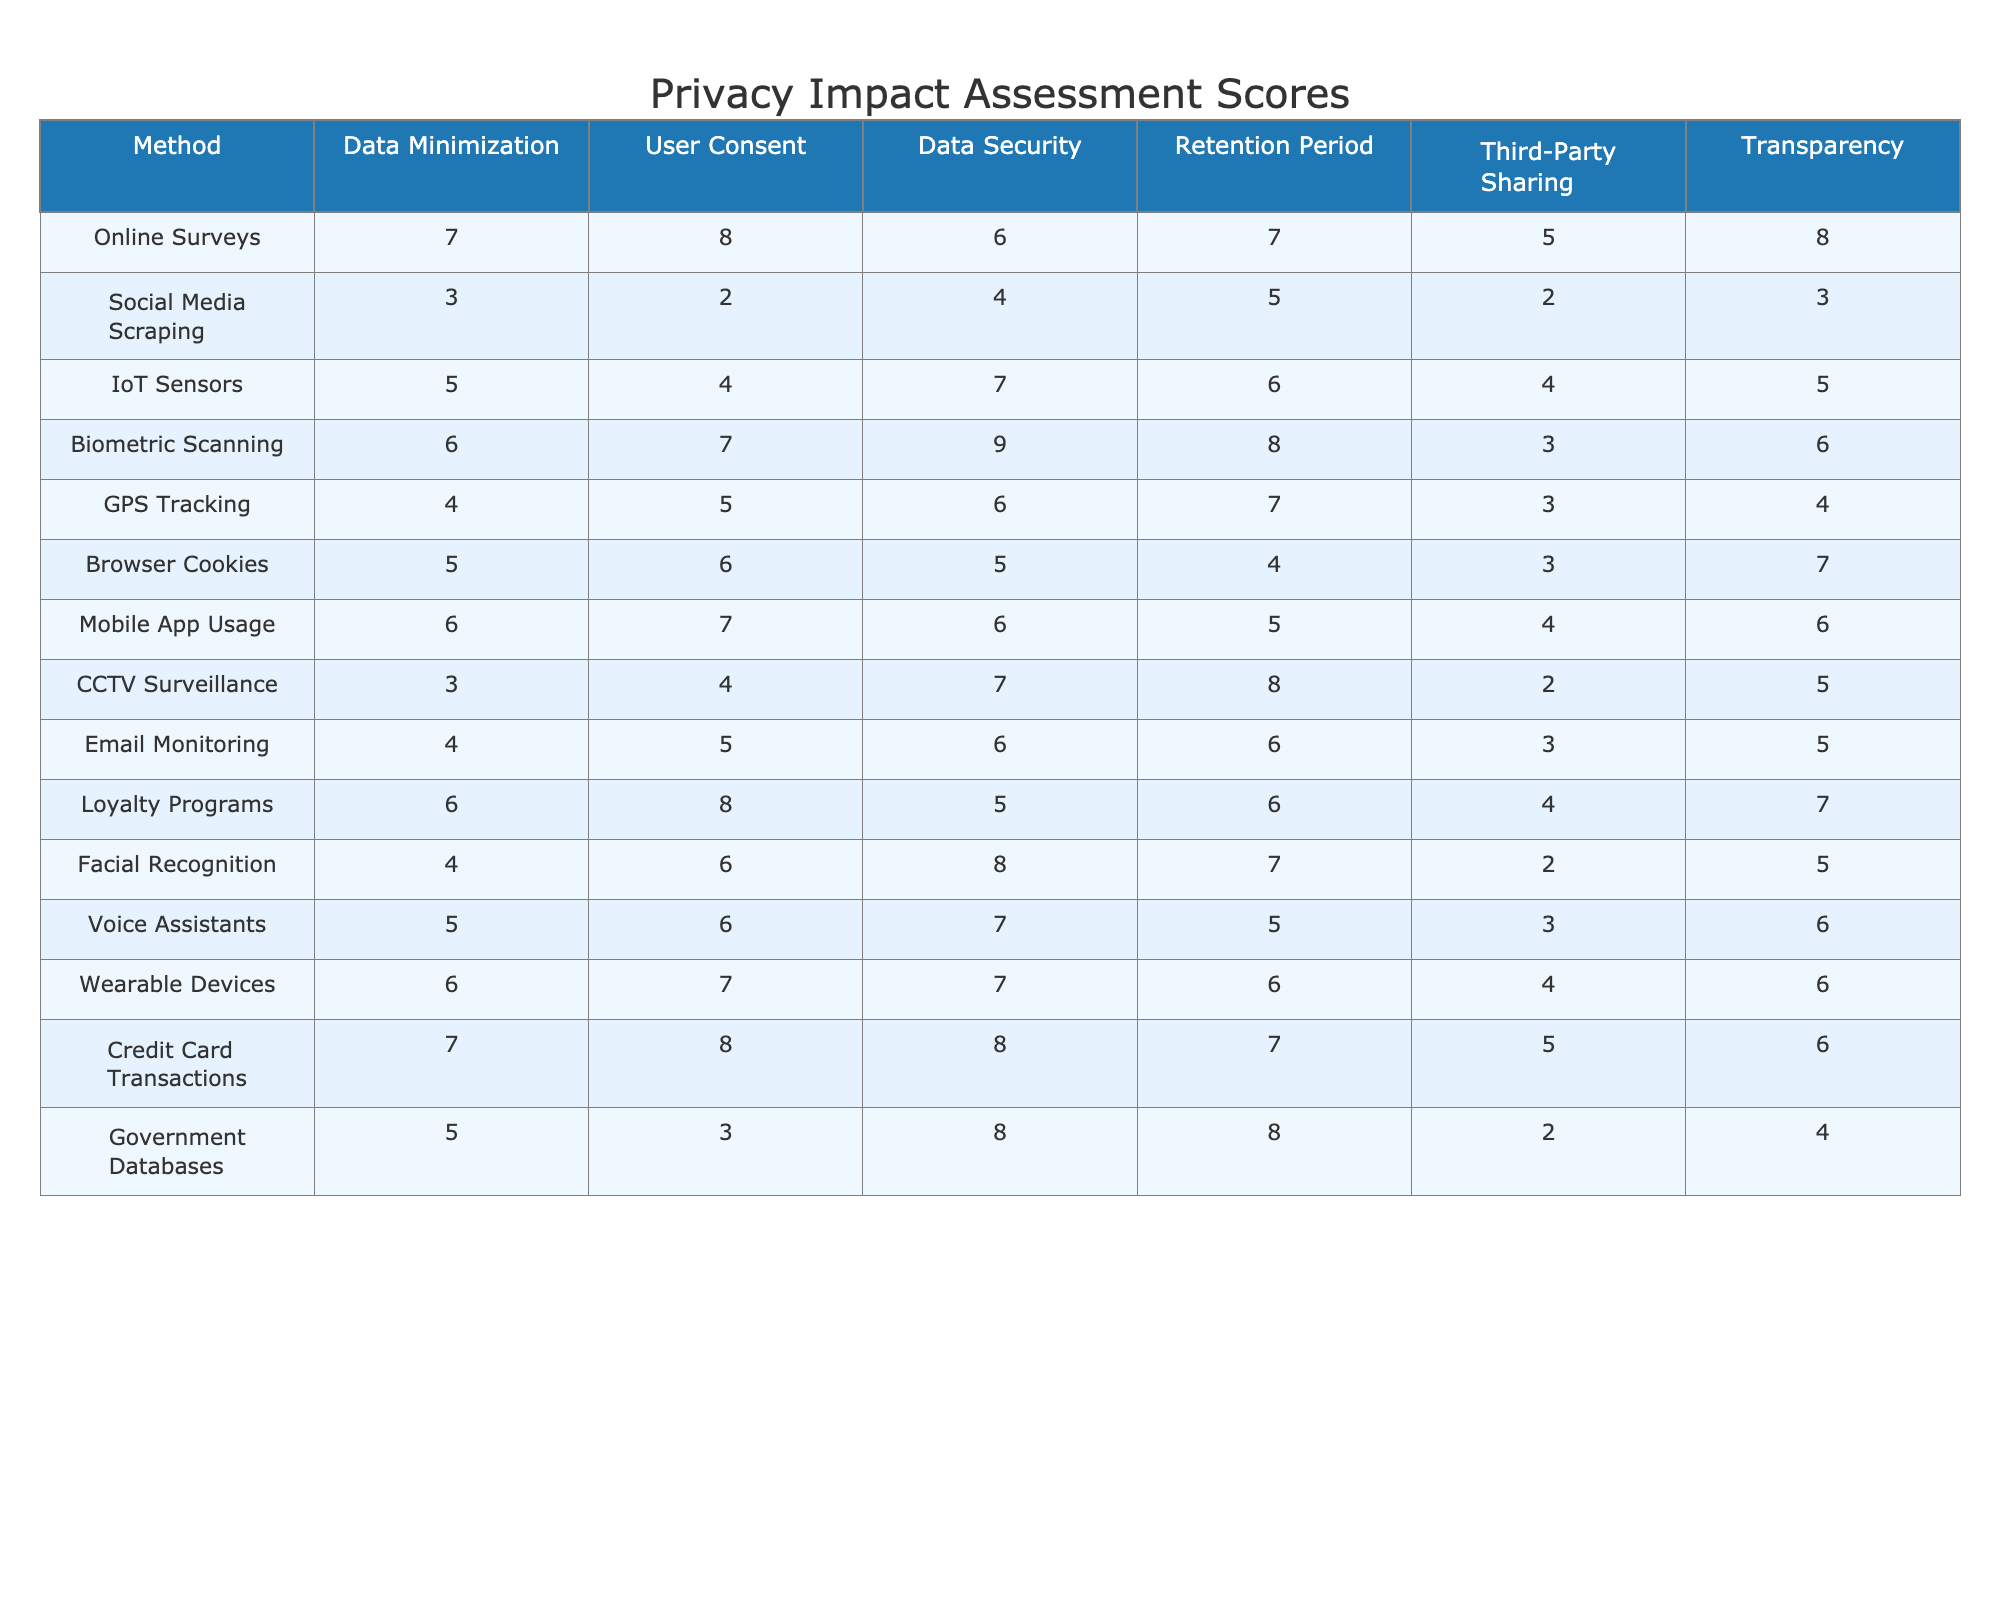What is the highest score for User Consent? The highest score for User Consent in the table is found by comparing all the values in the User Consent column. The highest value is 8, seen in Online Surveys and Loyalty Programs.
Answer: 8 Which method has the lowest Data Security score? By examining the Data Security column, we identify the lowest value. The lowest score is 4, which corresponds to Social Media Scraping.
Answer: 4 What is the average score for Data Minimization across all methods? To calculate the average for Data Minimization, we sum all the scores: (7 + 3 + 5 + 6 + 4 + 5 + 6 + 3 + 4 + 6 + 4 + 5 + 6 + 7 + 5) = 6, then divide by the number of methods (15). So, 6/15 = 4.
Answer: 4 Is there any method with a score of 2 in Third-Party Sharing? We check the Third-Party Sharing column for the value 2. The only method with this score is Social Media Scraping.
Answer: Yes What is the difference between the maximum and minimum values in the Retention Period column? The maximum score in the Retention Period column is 8 (CCTV Surveillance), and the minimum score is 4 (Browser Cookies). Therefore, the difference is 8 - 4 = 4.
Answer: 4 How many methods have a score of 6 or higher in Data Security? We check the Data Security column and count how many methods have a score of 6 or higher. The methods meeting this criterion are IoT Sensors, Biometric Scanning, CCTV Surveillance, and Credit Card Transactions. This totals 6 methods.
Answer: 6 Which data collection method has the highest score for Transparency? By examining the Transparency column, we see that Online Surveys and Loyalty Programs both score 8, which is the highest in this category.
Answer: 8 Are there more methods with a Data Minimization score of 5 than with a score of 4? We count: Data Minimization scores of 5 appear in Online Surveys, IoT Sensors, Browser Cookies, Mobile App Usage, and Loyalty Programs (5 total). For 4, they appear in Social Media Scraping, GPS Tracking, and Facial Recognition (3 total). Since 5 is greater than 3, the answer is yes.
Answer: Yes What are the top two methods with the highest average scores across all categories? First, we calculate the average scores for each method by summing the rows and dividing by the number of categories (6). The top two methods are Biometric Scanning (7.5) and Online Surveys (6.83).
Answer: Biometric Scanning, Online Surveys What is the overall trend in privacy scores for Social Media Scraping compared to Loyalty Programs? Calculating the average scores for each, Social Media Scraping has an average of 3.67 (low scores), while Loyalty Programs have an average of 6.33 (higher scores). Thus, Social Media Scraping scores lower trend-wise.
Answer: Lower trend for Social Media Scraping 